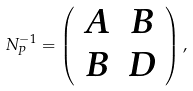<formula> <loc_0><loc_0><loc_500><loc_500>N _ { P } ^ { - 1 } = \left ( \begin{array} { c c } A & B \\ B & D \end{array} \right ) ,</formula> 